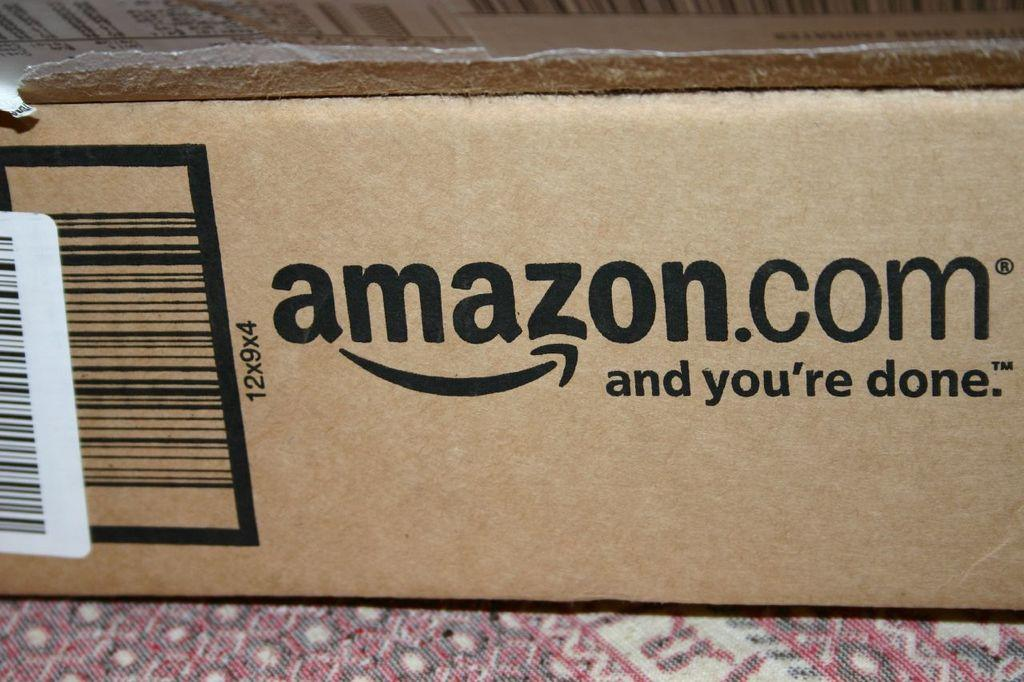<image>
Present a compact description of the photo's key features. a close up of an amazon.com box that says amazon.com and you're done. 